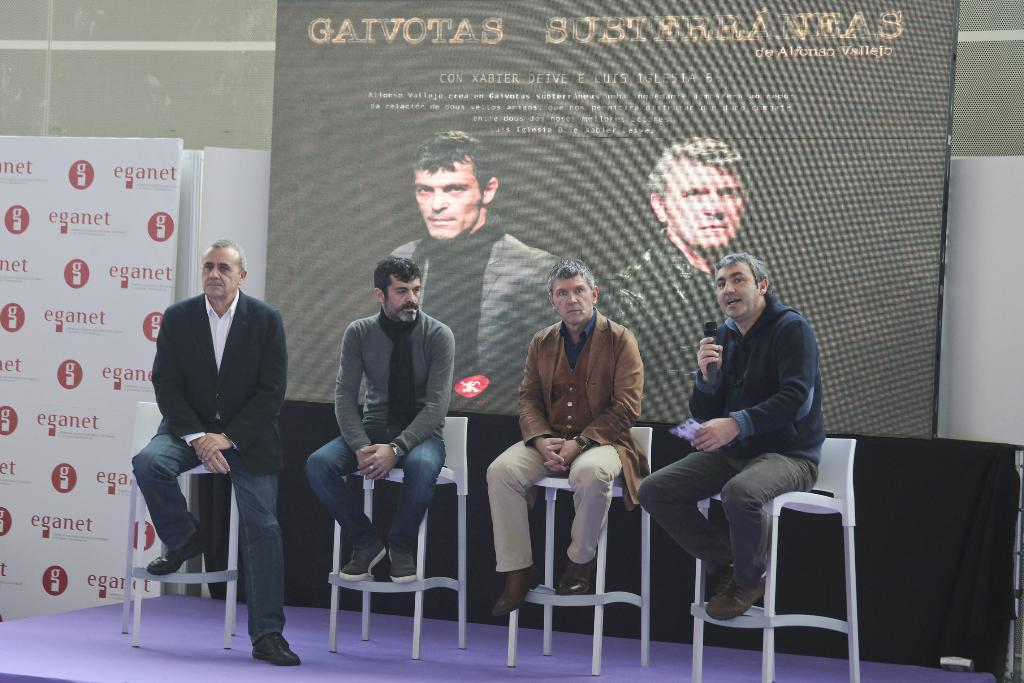How many people are in the image? There are four persons in the image. What are the four persons doing in the image? The four persons are sitting on a chair. Can you describe the person holding a mic? One man is holding a mic. What is present in the image besides the four persons? There is a banner in the image. What can be seen on the banner? The banner has pictures of persons on it. What type of glass is being used to create a fire in the image? There is no glass or fire present in the image. What color is the marble on the chair where the persons are sitting? There is no marble mentioned in the image; the chair is not described in detail. 